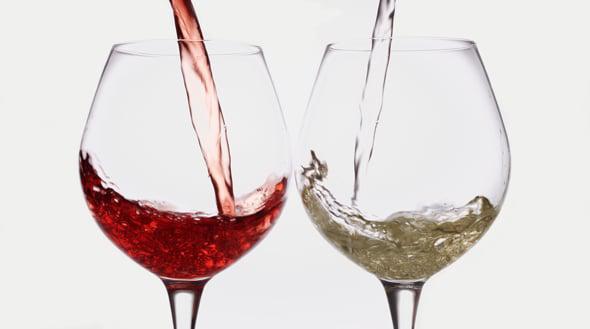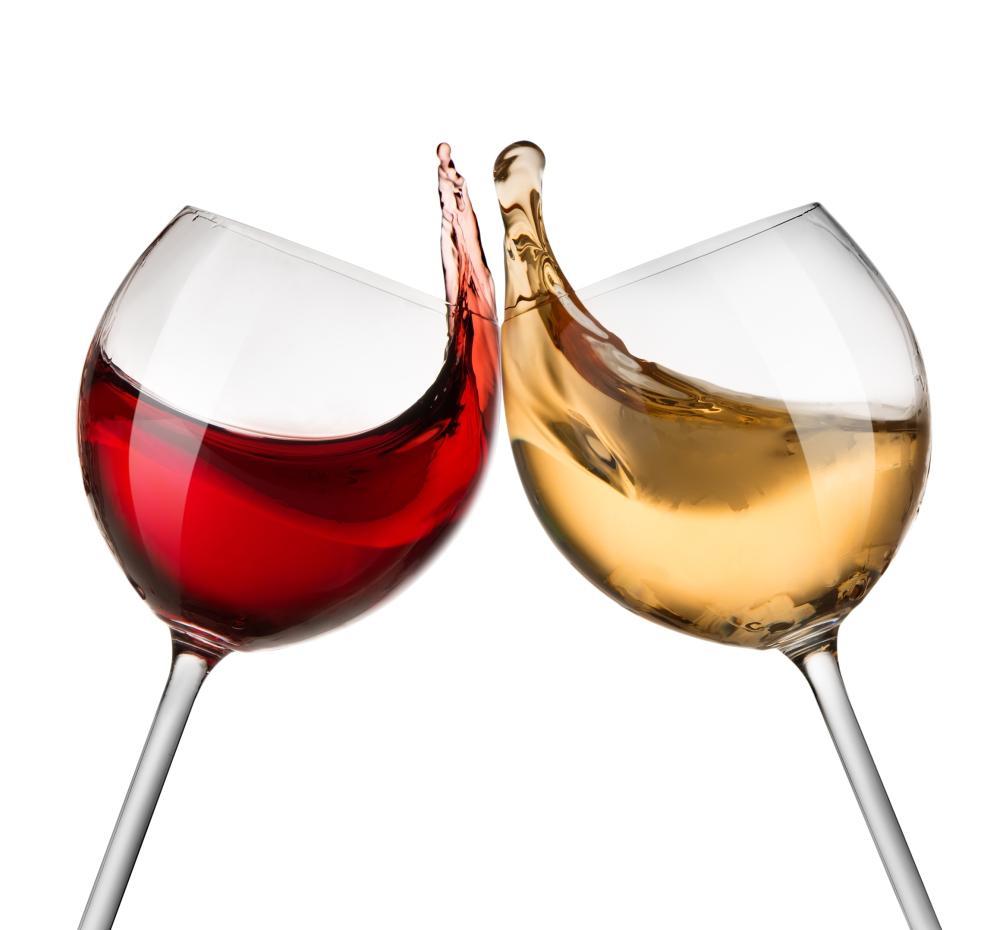The first image is the image on the left, the second image is the image on the right. Considering the images on both sides, is "In one image, two glasses of wine are sitting before at least one bottle." valid? Answer yes or no. No. 